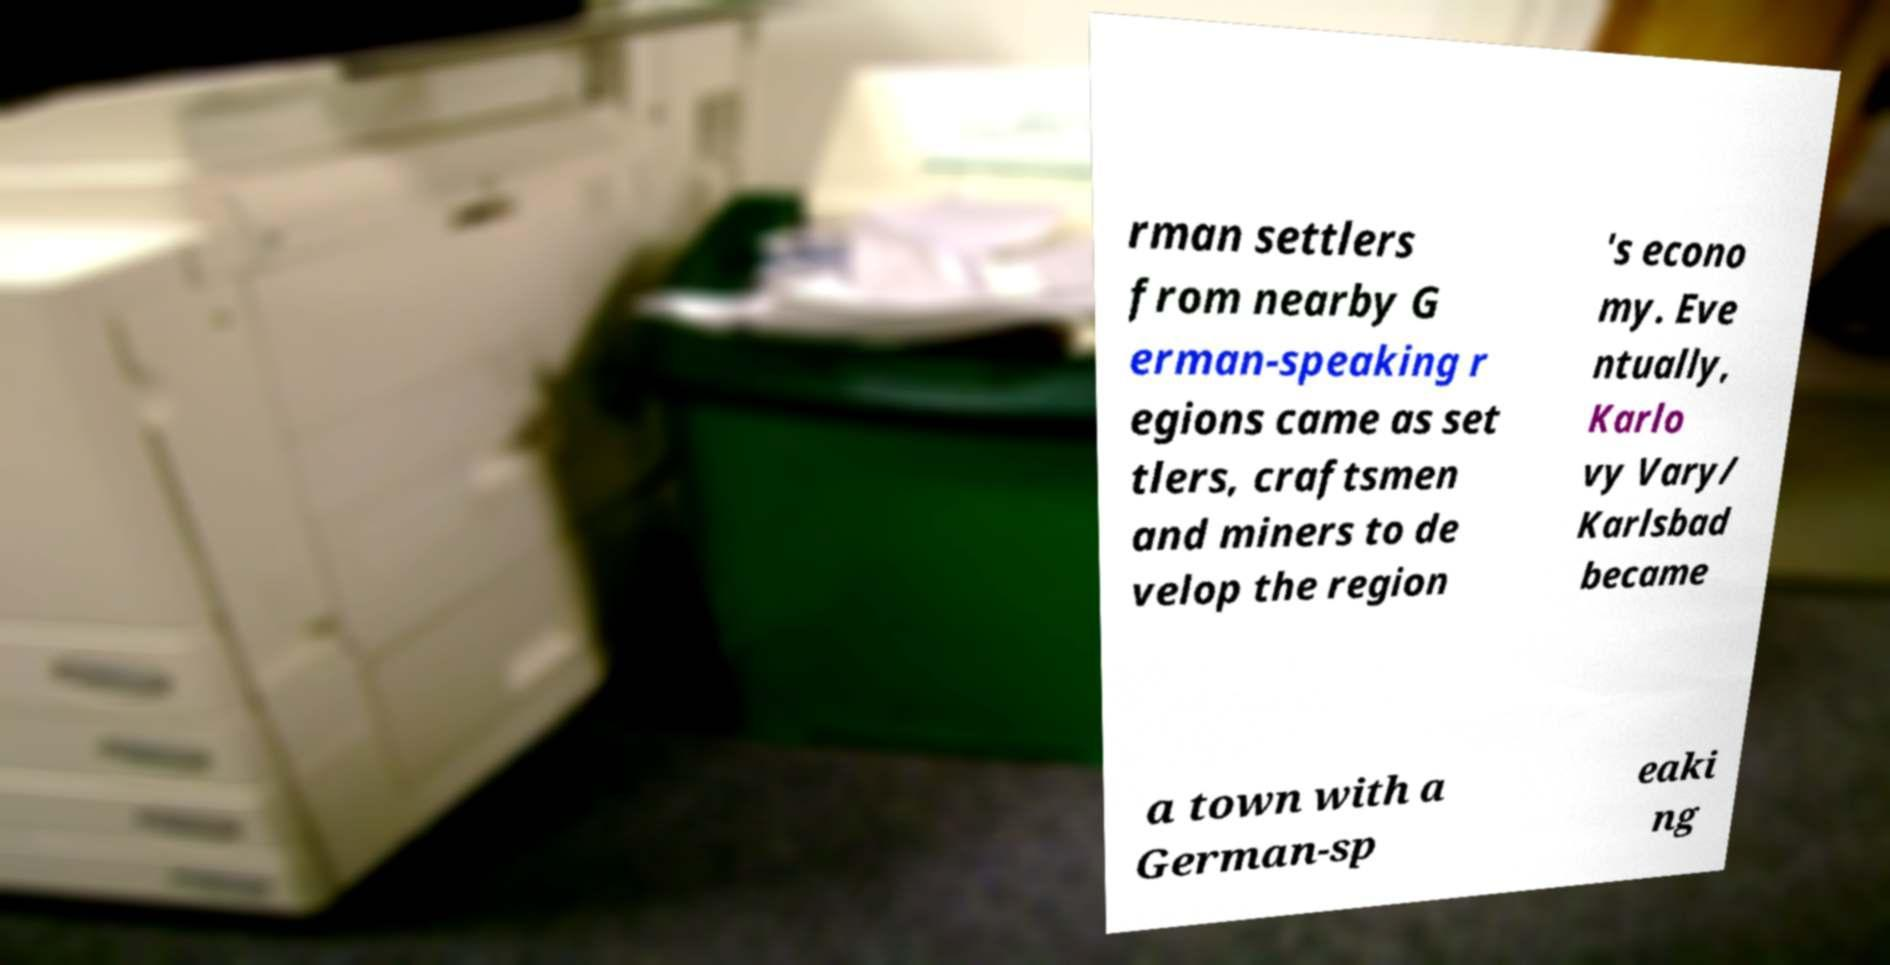Please read and relay the text visible in this image. What does it say? rman settlers from nearby G erman-speaking r egions came as set tlers, craftsmen and miners to de velop the region 's econo my. Eve ntually, Karlo vy Vary/ Karlsbad became a town with a German-sp eaki ng 